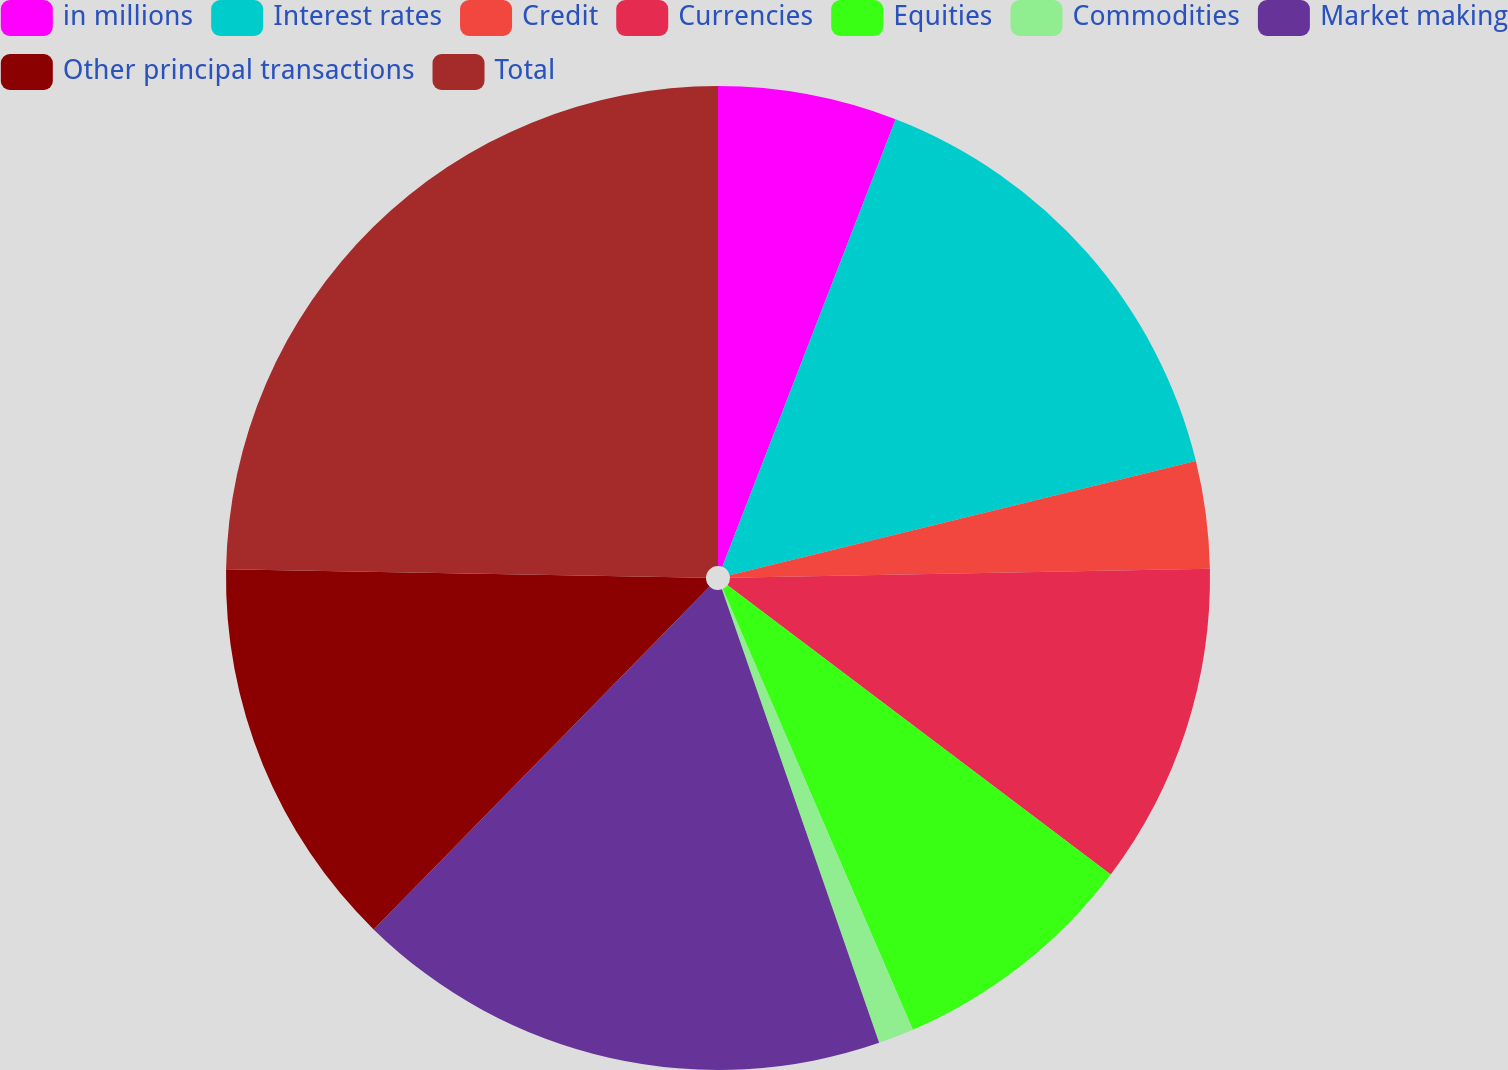<chart> <loc_0><loc_0><loc_500><loc_500><pie_chart><fcel>in millions<fcel>Interest rates<fcel>Credit<fcel>Currencies<fcel>Equities<fcel>Commodities<fcel>Market making<fcel>Other principal transactions<fcel>Total<nl><fcel>5.88%<fcel>15.3%<fcel>3.52%<fcel>10.59%<fcel>8.23%<fcel>1.17%<fcel>17.65%<fcel>12.94%<fcel>24.72%<nl></chart> 